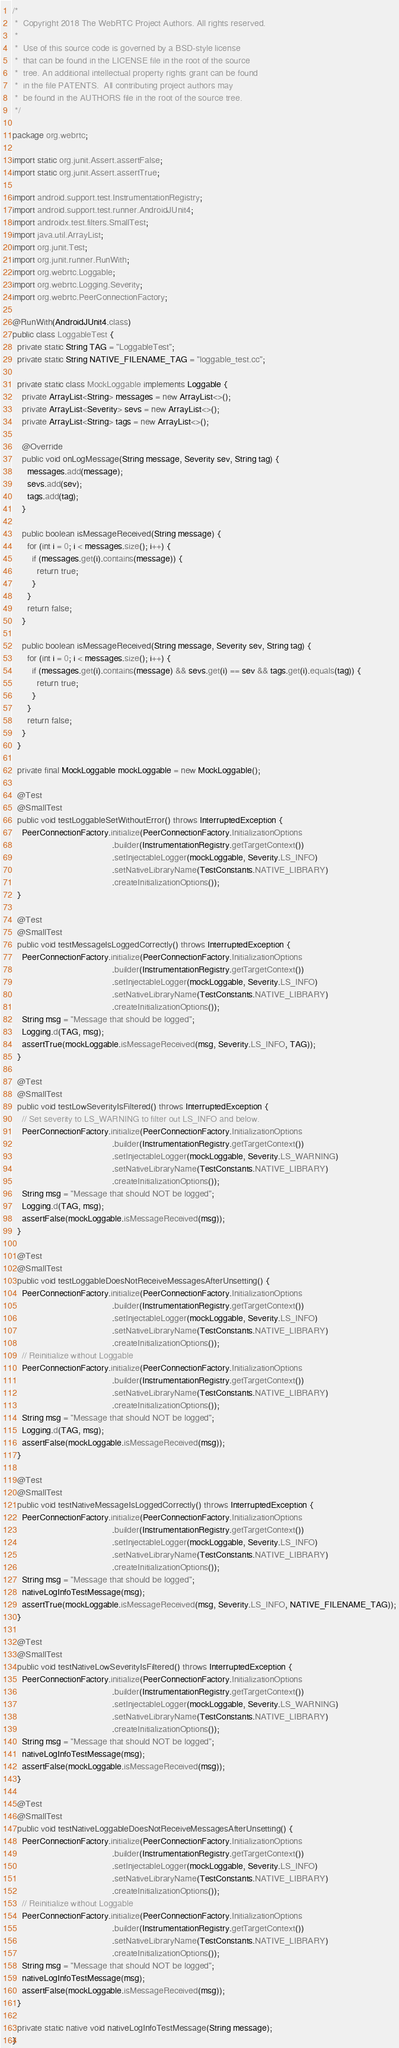<code> <loc_0><loc_0><loc_500><loc_500><_Java_>/*
 *  Copyright 2018 The WebRTC Project Authors. All rights reserved.
 *
 *  Use of this source code is governed by a BSD-style license
 *  that can be found in the LICENSE file in the root of the source
 *  tree. An additional intellectual property rights grant can be found
 *  in the file PATENTS.  All contributing project authors may
 *  be found in the AUTHORS file in the root of the source tree.
 */

package org.webrtc;

import static org.junit.Assert.assertFalse;
import static org.junit.Assert.assertTrue;

import android.support.test.InstrumentationRegistry;
import android.support.test.runner.AndroidJUnit4;
import androidx.test.filters.SmallTest;
import java.util.ArrayList;
import org.junit.Test;
import org.junit.runner.RunWith;
import org.webrtc.Loggable;
import org.webrtc.Logging.Severity;
import org.webrtc.PeerConnectionFactory;

@RunWith(AndroidJUnit4.class)
public class LoggableTest {
  private static String TAG = "LoggableTest";
  private static String NATIVE_FILENAME_TAG = "loggable_test.cc";

  private static class MockLoggable implements Loggable {
    private ArrayList<String> messages = new ArrayList<>();
    private ArrayList<Severity> sevs = new ArrayList<>();
    private ArrayList<String> tags = new ArrayList<>();

    @Override
    public void onLogMessage(String message, Severity sev, String tag) {
      messages.add(message);
      sevs.add(sev);
      tags.add(tag);
    }

    public boolean isMessageReceived(String message) {
      for (int i = 0; i < messages.size(); i++) {
        if (messages.get(i).contains(message)) {
          return true;
        }
      }
      return false;
    }

    public boolean isMessageReceived(String message, Severity sev, String tag) {
      for (int i = 0; i < messages.size(); i++) {
        if (messages.get(i).contains(message) && sevs.get(i) == sev && tags.get(i).equals(tag)) {
          return true;
        }
      }
      return false;
    }
  }

  private final MockLoggable mockLoggable = new MockLoggable();

  @Test
  @SmallTest
  public void testLoggableSetWithoutError() throws InterruptedException {
    PeerConnectionFactory.initialize(PeerConnectionFactory.InitializationOptions
                                         .builder(InstrumentationRegistry.getTargetContext())
                                         .setInjectableLogger(mockLoggable, Severity.LS_INFO)
                                         .setNativeLibraryName(TestConstants.NATIVE_LIBRARY)
                                         .createInitializationOptions());
  }

  @Test
  @SmallTest
  public void testMessageIsLoggedCorrectly() throws InterruptedException {
    PeerConnectionFactory.initialize(PeerConnectionFactory.InitializationOptions
                                         .builder(InstrumentationRegistry.getTargetContext())
                                         .setInjectableLogger(mockLoggable, Severity.LS_INFO)
                                         .setNativeLibraryName(TestConstants.NATIVE_LIBRARY)
                                         .createInitializationOptions());
    String msg = "Message that should be logged";
    Logging.d(TAG, msg);
    assertTrue(mockLoggable.isMessageReceived(msg, Severity.LS_INFO, TAG));
  }

  @Test
  @SmallTest
  public void testLowSeverityIsFiltered() throws InterruptedException {
    // Set severity to LS_WARNING to filter out LS_INFO and below.
    PeerConnectionFactory.initialize(PeerConnectionFactory.InitializationOptions
                                         .builder(InstrumentationRegistry.getTargetContext())
                                         .setInjectableLogger(mockLoggable, Severity.LS_WARNING)
                                         .setNativeLibraryName(TestConstants.NATIVE_LIBRARY)
                                         .createInitializationOptions());
    String msg = "Message that should NOT be logged";
    Logging.d(TAG, msg);
    assertFalse(mockLoggable.isMessageReceived(msg));
  }

  @Test
  @SmallTest
  public void testLoggableDoesNotReceiveMessagesAfterUnsetting() {
    PeerConnectionFactory.initialize(PeerConnectionFactory.InitializationOptions
                                         .builder(InstrumentationRegistry.getTargetContext())
                                         .setInjectableLogger(mockLoggable, Severity.LS_INFO)
                                         .setNativeLibraryName(TestConstants.NATIVE_LIBRARY)
                                         .createInitializationOptions());
    // Reinitialize without Loggable
    PeerConnectionFactory.initialize(PeerConnectionFactory.InitializationOptions
                                         .builder(InstrumentationRegistry.getTargetContext())
                                         .setNativeLibraryName(TestConstants.NATIVE_LIBRARY)
                                         .createInitializationOptions());
    String msg = "Message that should NOT be logged";
    Logging.d(TAG, msg);
    assertFalse(mockLoggable.isMessageReceived(msg));
  }

  @Test
  @SmallTest
  public void testNativeMessageIsLoggedCorrectly() throws InterruptedException {
    PeerConnectionFactory.initialize(PeerConnectionFactory.InitializationOptions
                                         .builder(InstrumentationRegistry.getTargetContext())
                                         .setInjectableLogger(mockLoggable, Severity.LS_INFO)
                                         .setNativeLibraryName(TestConstants.NATIVE_LIBRARY)
                                         .createInitializationOptions());
    String msg = "Message that should be logged";
    nativeLogInfoTestMessage(msg);
    assertTrue(mockLoggable.isMessageReceived(msg, Severity.LS_INFO, NATIVE_FILENAME_TAG));
  }

  @Test
  @SmallTest
  public void testNativeLowSeverityIsFiltered() throws InterruptedException {
    PeerConnectionFactory.initialize(PeerConnectionFactory.InitializationOptions
                                         .builder(InstrumentationRegistry.getTargetContext())
                                         .setInjectableLogger(mockLoggable, Severity.LS_WARNING)
                                         .setNativeLibraryName(TestConstants.NATIVE_LIBRARY)
                                         .createInitializationOptions());
    String msg = "Message that should NOT be logged";
    nativeLogInfoTestMessage(msg);
    assertFalse(mockLoggable.isMessageReceived(msg));
  }

  @Test
  @SmallTest
  public void testNativeLoggableDoesNotReceiveMessagesAfterUnsetting() {
    PeerConnectionFactory.initialize(PeerConnectionFactory.InitializationOptions
                                         .builder(InstrumentationRegistry.getTargetContext())
                                         .setInjectableLogger(mockLoggable, Severity.LS_INFO)
                                         .setNativeLibraryName(TestConstants.NATIVE_LIBRARY)
                                         .createInitializationOptions());
    // Reinitialize without Loggable
    PeerConnectionFactory.initialize(PeerConnectionFactory.InitializationOptions
                                         .builder(InstrumentationRegistry.getTargetContext())
                                         .setNativeLibraryName(TestConstants.NATIVE_LIBRARY)
                                         .createInitializationOptions());
    String msg = "Message that should NOT be logged";
    nativeLogInfoTestMessage(msg);
    assertFalse(mockLoggable.isMessageReceived(msg));
  }

  private static native void nativeLogInfoTestMessage(String message);
}
</code> 